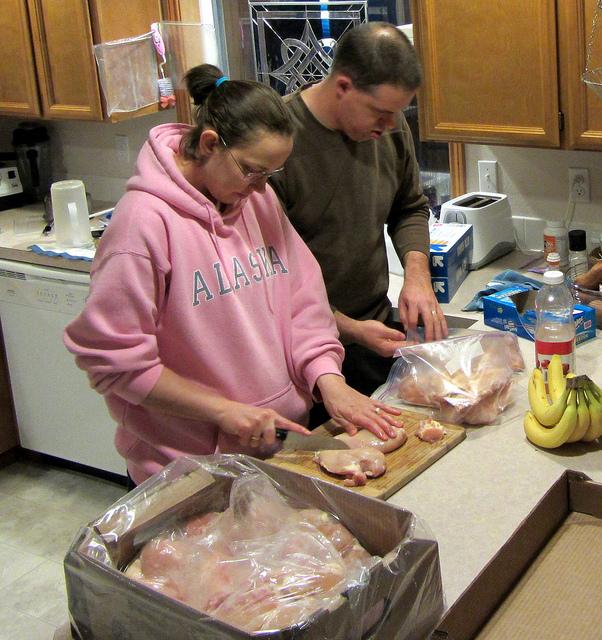What is written on the woman's hoodie?
Concise answer only. Alaska. What are they making?
Give a very brief answer. Chicken. What meat is being cut?
Keep it brief. Chicken. 